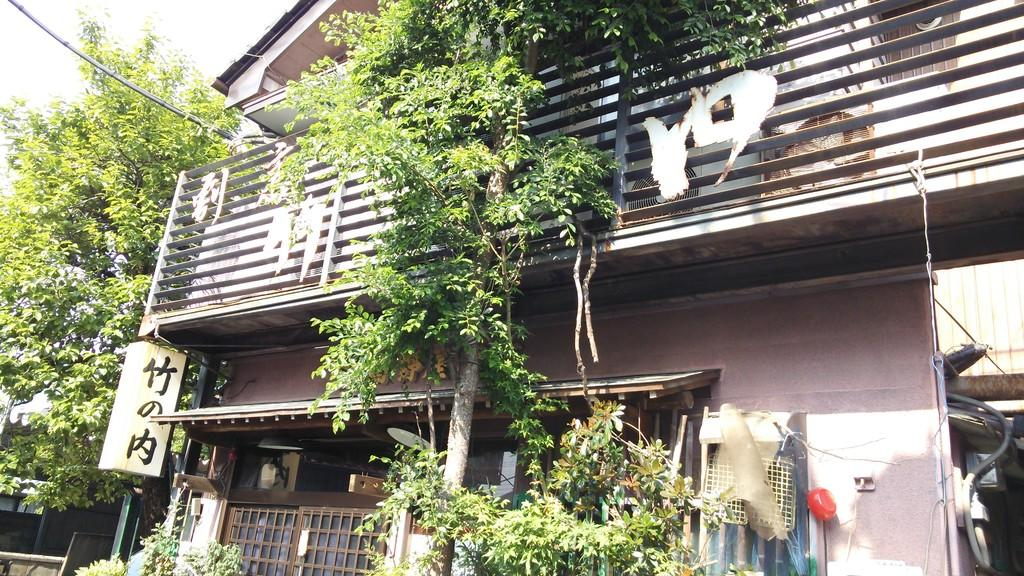What type of structure is present in the image? There is a building in the image. What else can be seen in the image besides the building? There is writing and trees in the image. What is the color of the image? The image has a white color. Can you see a cable being kicked in the image? There is no cable or kicking action present in the image. 